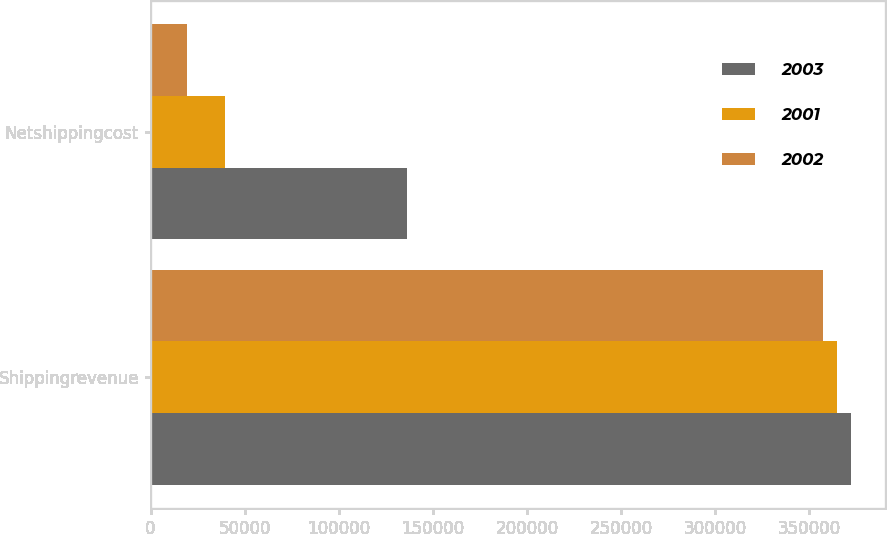Convert chart to OTSL. <chart><loc_0><loc_0><loc_500><loc_500><stacked_bar_chart><ecel><fcel>Shippingrevenue<fcel>Netshippingcost<nl><fcel>2003<fcel>372000<fcel>136468<nl><fcel>2001<fcel>364749<fcel>39554<nl><fcel>2002<fcel>357325<fcel>19163<nl></chart> 